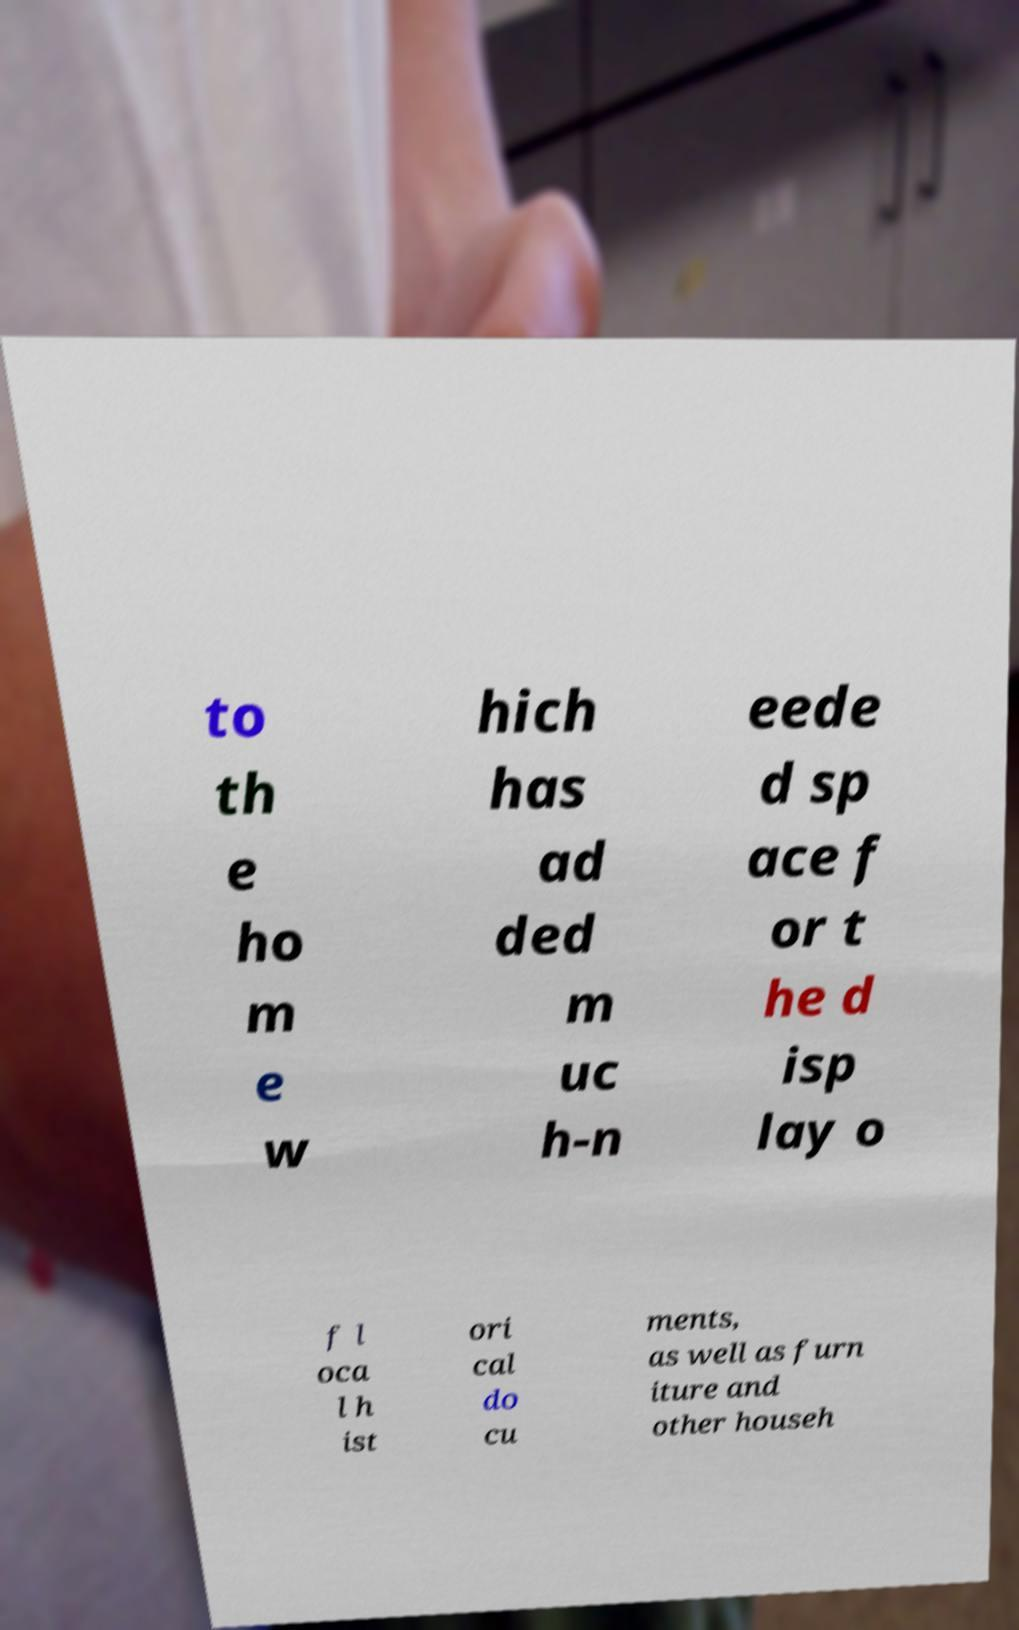There's text embedded in this image that I need extracted. Can you transcribe it verbatim? to th e ho m e w hich has ad ded m uc h-n eede d sp ace f or t he d isp lay o f l oca l h ist ori cal do cu ments, as well as furn iture and other househ 